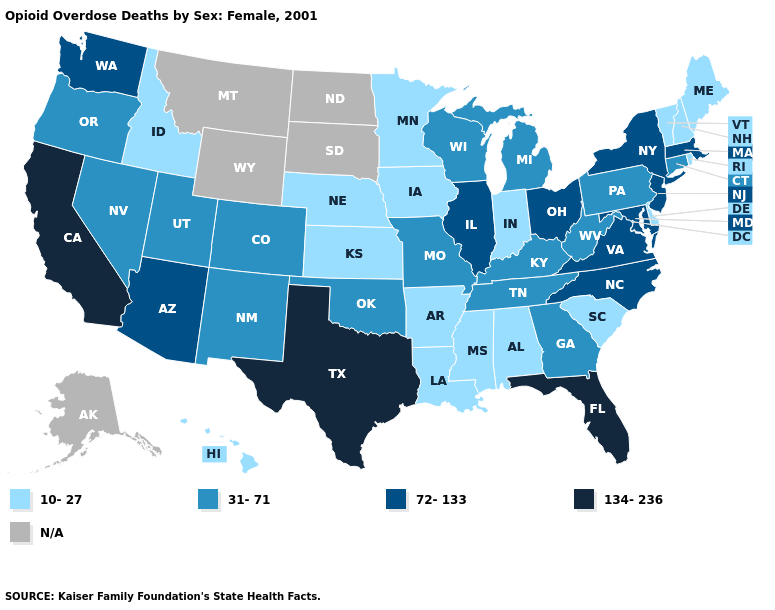Among the states that border Rhode Island , which have the highest value?
Short answer required. Massachusetts. Name the states that have a value in the range 10-27?
Concise answer only. Alabama, Arkansas, Delaware, Hawaii, Idaho, Indiana, Iowa, Kansas, Louisiana, Maine, Minnesota, Mississippi, Nebraska, New Hampshire, Rhode Island, South Carolina, Vermont. Name the states that have a value in the range 134-236?
Concise answer only. California, Florida, Texas. Name the states that have a value in the range 72-133?
Quick response, please. Arizona, Illinois, Maryland, Massachusetts, New Jersey, New York, North Carolina, Ohio, Virginia, Washington. What is the highest value in states that border New Mexico?
Give a very brief answer. 134-236. Does Colorado have the highest value in the West?
Write a very short answer. No. Name the states that have a value in the range 134-236?
Give a very brief answer. California, Florida, Texas. What is the value of North Dakota?
Write a very short answer. N/A. Does California have the highest value in the USA?
Give a very brief answer. Yes. Does the map have missing data?
Keep it brief. Yes. What is the value of New Hampshire?
Be succinct. 10-27. What is the highest value in the Northeast ?
Quick response, please. 72-133. How many symbols are there in the legend?
Concise answer only. 5. Name the states that have a value in the range 134-236?
Give a very brief answer. California, Florida, Texas. Name the states that have a value in the range N/A?
Quick response, please. Alaska, Montana, North Dakota, South Dakota, Wyoming. 